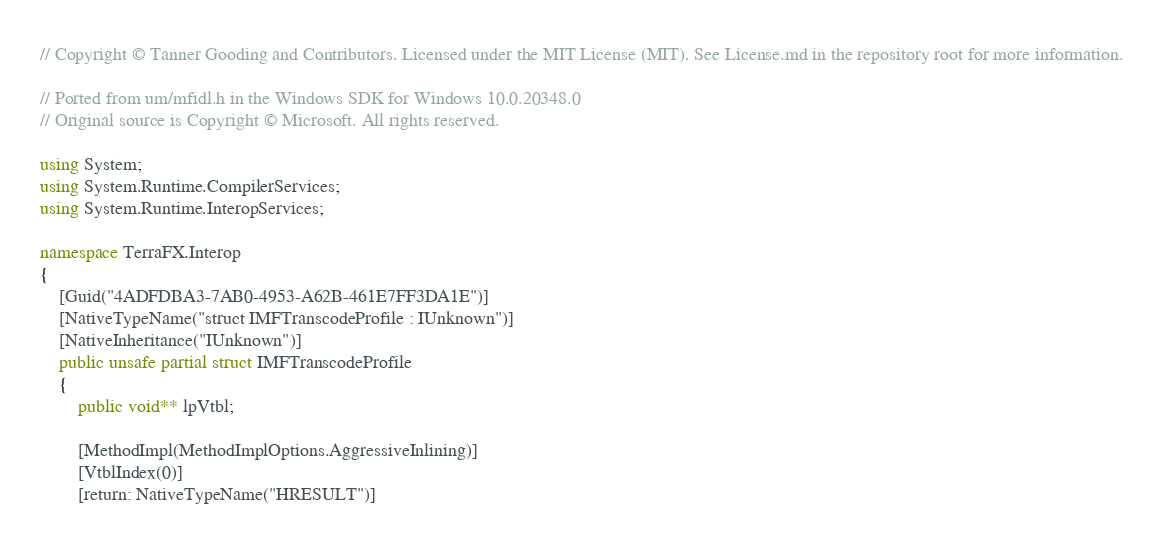<code> <loc_0><loc_0><loc_500><loc_500><_C#_>// Copyright © Tanner Gooding and Contributors. Licensed under the MIT License (MIT). See License.md in the repository root for more information.

// Ported from um/mfidl.h in the Windows SDK for Windows 10.0.20348.0
// Original source is Copyright © Microsoft. All rights reserved.

using System;
using System.Runtime.CompilerServices;
using System.Runtime.InteropServices;

namespace TerraFX.Interop
{
    [Guid("4ADFDBA3-7AB0-4953-A62B-461E7FF3DA1E")]
    [NativeTypeName("struct IMFTranscodeProfile : IUnknown")]
    [NativeInheritance("IUnknown")]
    public unsafe partial struct IMFTranscodeProfile
    {
        public void** lpVtbl;

        [MethodImpl(MethodImplOptions.AggressiveInlining)]
        [VtblIndex(0)]
        [return: NativeTypeName("HRESULT")]</code> 